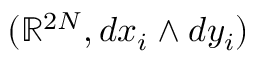<formula> <loc_0><loc_0><loc_500><loc_500>( \mathbb { R } ^ { 2 N } , d x _ { i } \wedge d y _ { i } )</formula> 